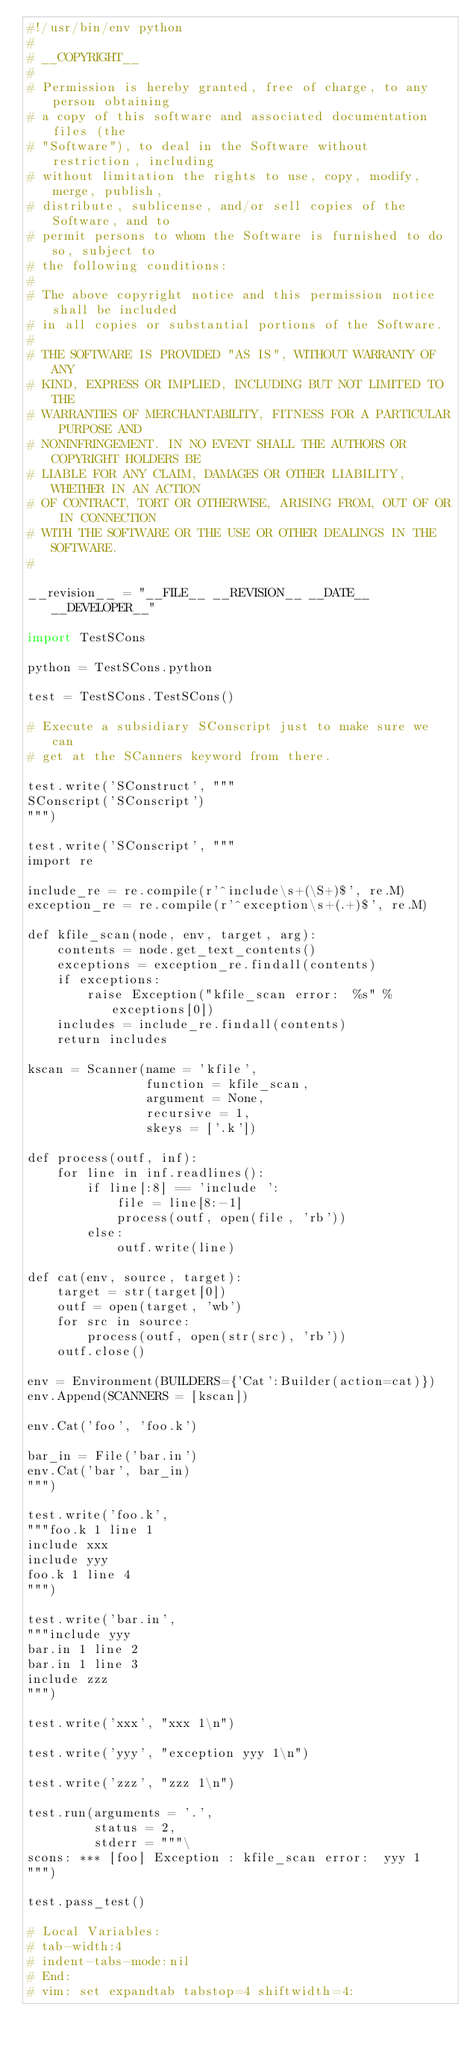Convert code to text. <code><loc_0><loc_0><loc_500><loc_500><_Python_>#!/usr/bin/env python
#
# __COPYRIGHT__
#
# Permission is hereby granted, free of charge, to any person obtaining
# a copy of this software and associated documentation files (the
# "Software"), to deal in the Software without restriction, including
# without limitation the rights to use, copy, modify, merge, publish,
# distribute, sublicense, and/or sell copies of the Software, and to
# permit persons to whom the Software is furnished to do so, subject to
# the following conditions:
#
# The above copyright notice and this permission notice shall be included
# in all copies or substantial portions of the Software.
#
# THE SOFTWARE IS PROVIDED "AS IS", WITHOUT WARRANTY OF ANY
# KIND, EXPRESS OR IMPLIED, INCLUDING BUT NOT LIMITED TO THE
# WARRANTIES OF MERCHANTABILITY, FITNESS FOR A PARTICULAR PURPOSE AND
# NONINFRINGEMENT. IN NO EVENT SHALL THE AUTHORS OR COPYRIGHT HOLDERS BE
# LIABLE FOR ANY CLAIM, DAMAGES OR OTHER LIABILITY, WHETHER IN AN ACTION
# OF CONTRACT, TORT OR OTHERWISE, ARISING FROM, OUT OF OR IN CONNECTION
# WITH THE SOFTWARE OR THE USE OR OTHER DEALINGS IN THE SOFTWARE.
#

__revision__ = "__FILE__ __REVISION__ __DATE__ __DEVELOPER__"

import TestSCons

python = TestSCons.python

test = TestSCons.TestSCons()

# Execute a subsidiary SConscript just to make sure we can
# get at the SCanners keyword from there.

test.write('SConstruct', """
SConscript('SConscript')
""")

test.write('SConscript', """
import re

include_re = re.compile(r'^include\s+(\S+)$', re.M)
exception_re = re.compile(r'^exception\s+(.+)$', re.M)

def kfile_scan(node, env, target, arg):
    contents = node.get_text_contents()
    exceptions = exception_re.findall(contents)
    if exceptions:
        raise Exception("kfile_scan error:  %s" % exceptions[0])
    includes = include_re.findall(contents)
    return includes

kscan = Scanner(name = 'kfile',
                function = kfile_scan,
                argument = None,
                recursive = 1,
                skeys = ['.k'])

def process(outf, inf):
    for line in inf.readlines():
        if line[:8] == 'include ':
            file = line[8:-1]
            process(outf, open(file, 'rb'))
        else:
            outf.write(line)

def cat(env, source, target):
    target = str(target[0])
    outf = open(target, 'wb')
    for src in source:
        process(outf, open(str(src), 'rb'))
    outf.close()

env = Environment(BUILDERS={'Cat':Builder(action=cat)})
env.Append(SCANNERS = [kscan])

env.Cat('foo', 'foo.k')

bar_in = File('bar.in')
env.Cat('bar', bar_in)
""")

test.write('foo.k', 
"""foo.k 1 line 1
include xxx
include yyy
foo.k 1 line 4
""")

test.write('bar.in', 
"""include yyy
bar.in 1 line 2
bar.in 1 line 3
include zzz
""")

test.write('xxx', "xxx 1\n")

test.write('yyy', "exception yyy 1\n")

test.write('zzz', "zzz 1\n")

test.run(arguments = '.',
         status = 2,
         stderr = """\
scons: *** [foo] Exception : kfile_scan error:  yyy 1
""")

test.pass_test()

# Local Variables:
# tab-width:4
# indent-tabs-mode:nil
# End:
# vim: set expandtab tabstop=4 shiftwidth=4:
</code> 